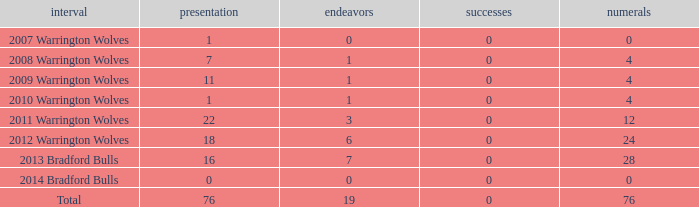What is the average tries for the season 2008 warrington wolves with an appearance more than 7? None. 